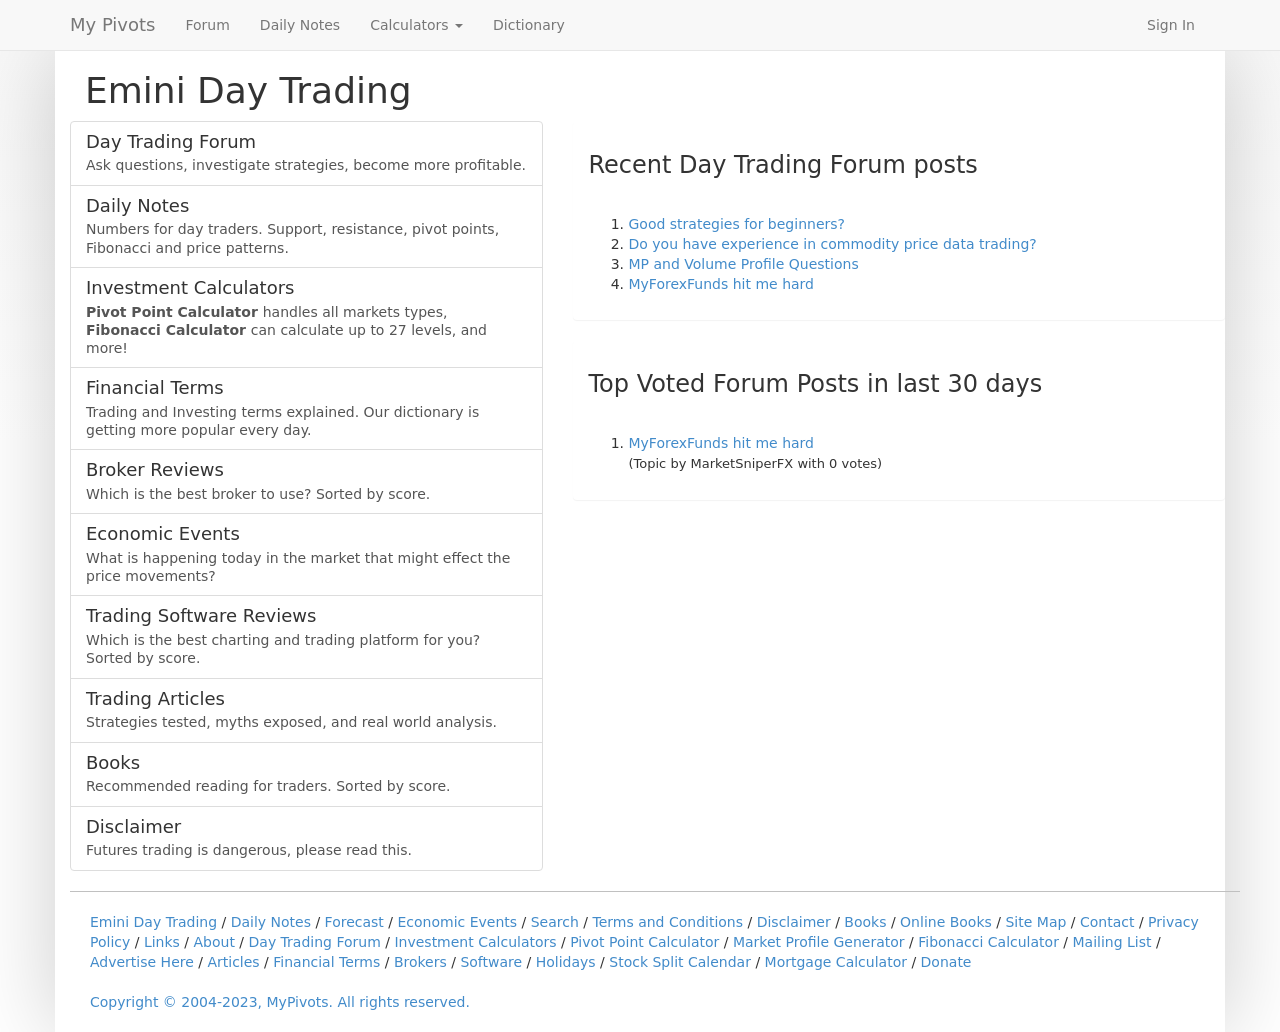What elements would make the 'Emini Day Trading' section in the image more interactive? To enhance interactivity, consider adding a real-time chart that updates with market movements, interactive calculators directly within the section, or even a forum preview where recent topics and active discussions are dynamically updated.  Could you suggest some technology stack improvements for the website shown? For the website in the image, using a JavaScript framework like React could enhance UI interactivity. Server-side, Node.js combined with Express could handle realtime data efficiently. Incorporate MongoDB for data storage to handle large volumes of user and market data efficiently. 